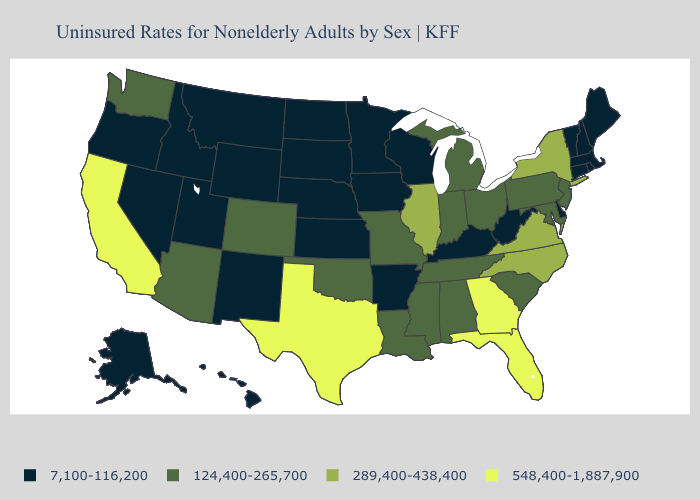What is the value of Iowa?
Answer briefly. 7,100-116,200. What is the value of Wisconsin?
Short answer required. 7,100-116,200. What is the value of Arizona?
Keep it brief. 124,400-265,700. What is the value of Ohio?
Be succinct. 124,400-265,700. What is the value of Mississippi?
Give a very brief answer. 124,400-265,700. Which states have the lowest value in the USA?
Be succinct. Alaska, Arkansas, Connecticut, Delaware, Hawaii, Idaho, Iowa, Kansas, Kentucky, Maine, Massachusetts, Minnesota, Montana, Nebraska, Nevada, New Hampshire, New Mexico, North Dakota, Oregon, Rhode Island, South Dakota, Utah, Vermont, West Virginia, Wisconsin, Wyoming. Does Colorado have a higher value than Arizona?
Concise answer only. No. What is the value of Vermont?
Quick response, please. 7,100-116,200. Which states have the lowest value in the South?
Write a very short answer. Arkansas, Delaware, Kentucky, West Virginia. Among the states that border Maine , which have the lowest value?
Concise answer only. New Hampshire. What is the lowest value in the USA?
Give a very brief answer. 7,100-116,200. What is the highest value in the MidWest ?
Keep it brief. 289,400-438,400. Which states have the highest value in the USA?
Answer briefly. California, Florida, Georgia, Texas. What is the value of South Dakota?
Quick response, please. 7,100-116,200. 